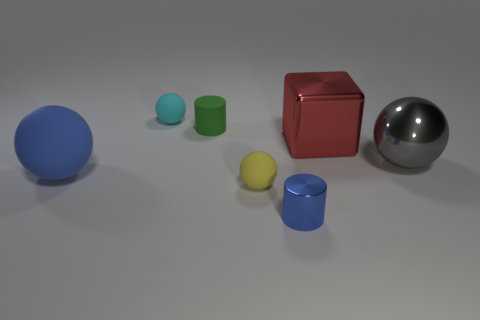What number of tiny spheres are both in front of the metallic block and behind the red object?
Give a very brief answer. 0. What material is the big cube in front of the small matte ball behind the big shiny ball made of?
Provide a short and direct response. Metal. There is a gray object that is the same shape as the yellow matte thing; what is its material?
Give a very brief answer. Metal. Are there any yellow rubber spheres?
Your answer should be very brief. Yes. What is the shape of the blue object that is made of the same material as the green thing?
Provide a succinct answer. Sphere. There is a large ball that is behind the large blue ball; what is its material?
Ensure brevity in your answer.  Metal. There is a tiny metallic thing right of the cyan matte thing; does it have the same color as the large matte sphere?
Offer a very short reply. Yes. There is a cylinder behind the metal object on the right side of the red object; how big is it?
Your answer should be compact. Small. Are there more large metallic objects that are right of the blue ball than large brown metallic balls?
Make the answer very short. Yes. Does the cylinder that is in front of the gray thing have the same size as the tiny cyan object?
Ensure brevity in your answer.  Yes. 